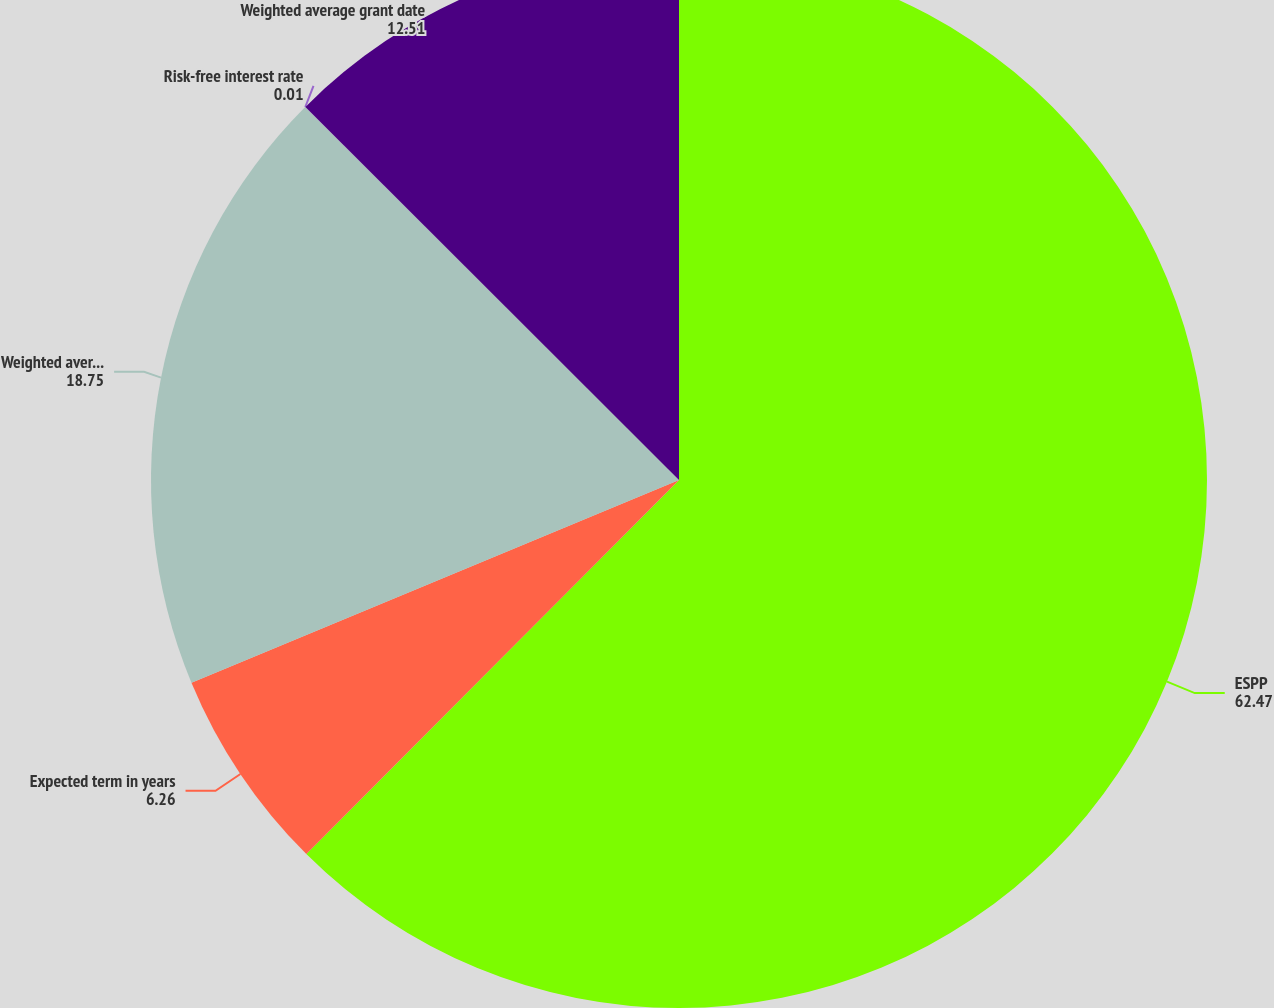<chart> <loc_0><loc_0><loc_500><loc_500><pie_chart><fcel>ESPP<fcel>Expected term in years<fcel>Weighted average expected<fcel>Risk-free interest rate<fcel>Weighted average grant date<nl><fcel>62.47%<fcel>6.26%<fcel>18.75%<fcel>0.01%<fcel>12.51%<nl></chart> 